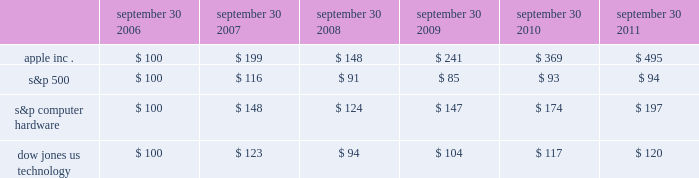Company stock performance the following graph shows a five-year comparison of cumulative total shareholder return , calculated on a dividend reinvested basis , for the company , the s&p 500 composite index , the s&p computer hardware index , and the dow jones u.s .
Technology index .
The graph assumes $ 100 was invested in each of the company 2019s common stock , the s&p 500 composite index , the s&p computer hardware index , and the dow jones u.s .
Technology index on september 30 , 2006 .
Data points on the graph are annual .
Note that historic stock price performance is not necessarily indicative of future stock price performance .
Comparison of 5 year cumulative total return* among apple inc. , the s&p 500 index , the s&p computer hardware index and the dow jones us technology index sep-10sep-09sep-08sep-07sep-06 sep-11 apple inc .
S&p 500 s&p computer hardware dow jones us technology *$ 100 invested on 9/30/06 in stock or index , including reinvestment of dividends .
Fiscal year ending september 30 .
Copyright a9 2011 s&p , a division of the mcgraw-hill companies inc .
All rights reserved .
Copyright a9 2011 dow jones & co .
All rights reserved .
September 30 , september 30 , september 30 , september 30 , september 30 , september 30 .

Did apple achieve a greater return in the year ended sept . 30 2009 than the s&p 500? 
Computations: (241 > 85)
Answer: yes. 